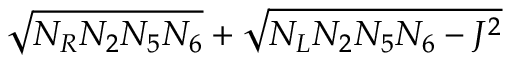<formula> <loc_0><loc_0><loc_500><loc_500>\sqrt { N _ { R } N _ { 2 } N _ { 5 } N _ { 6 } } + \sqrt { N _ { L } N _ { 2 } N _ { 5 } N _ { 6 } - J ^ { 2 } }</formula> 